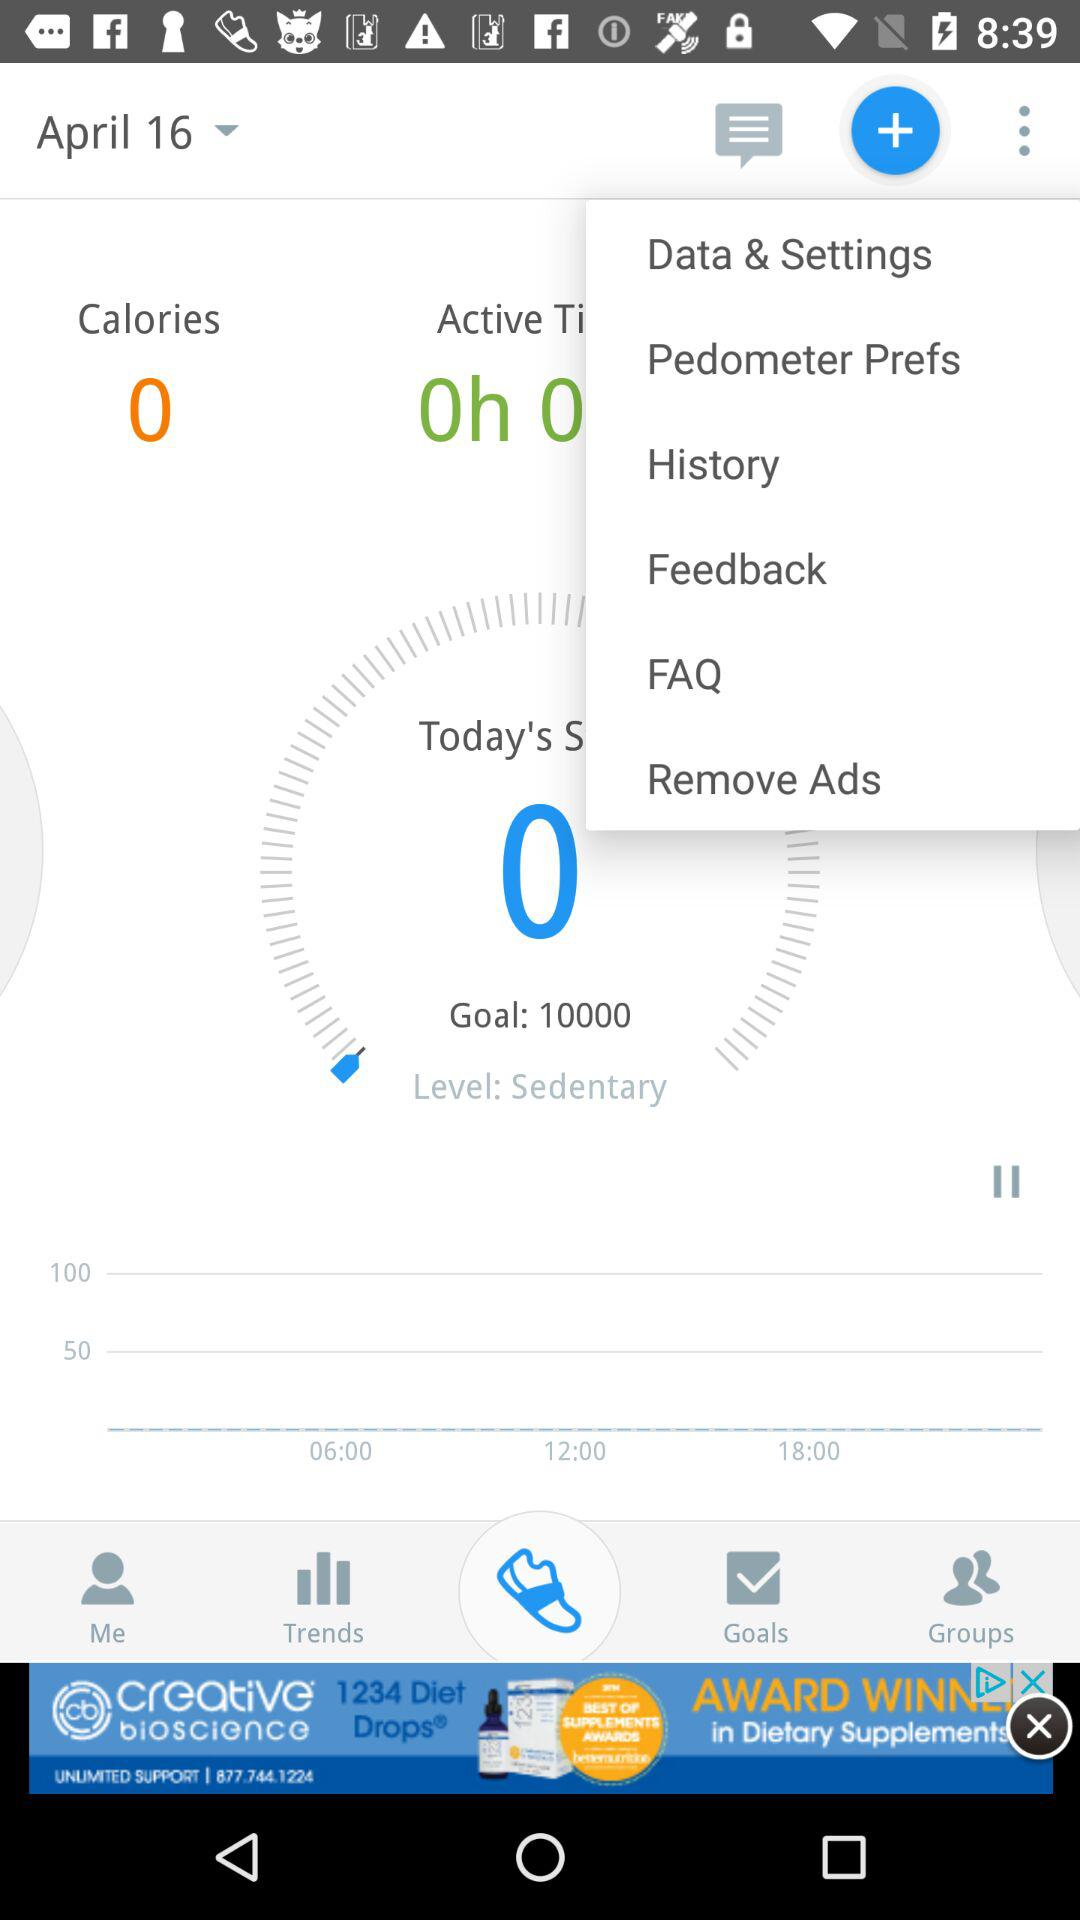What is the date? The date is April 16. 